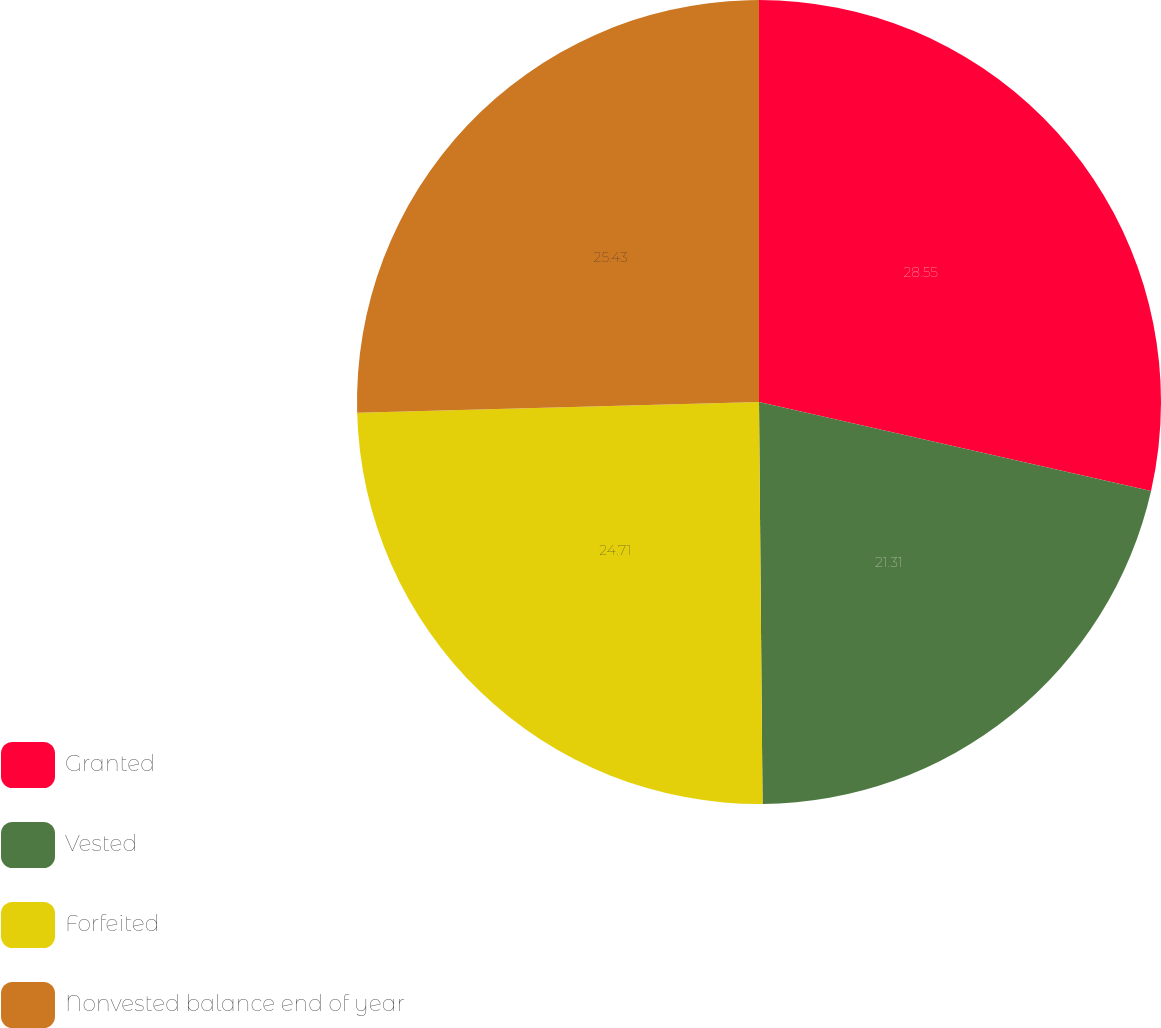<chart> <loc_0><loc_0><loc_500><loc_500><pie_chart><fcel>Granted<fcel>Vested<fcel>Forfeited<fcel>Nonvested balance end of year<nl><fcel>28.55%<fcel>21.31%<fcel>24.71%<fcel>25.43%<nl></chart> 